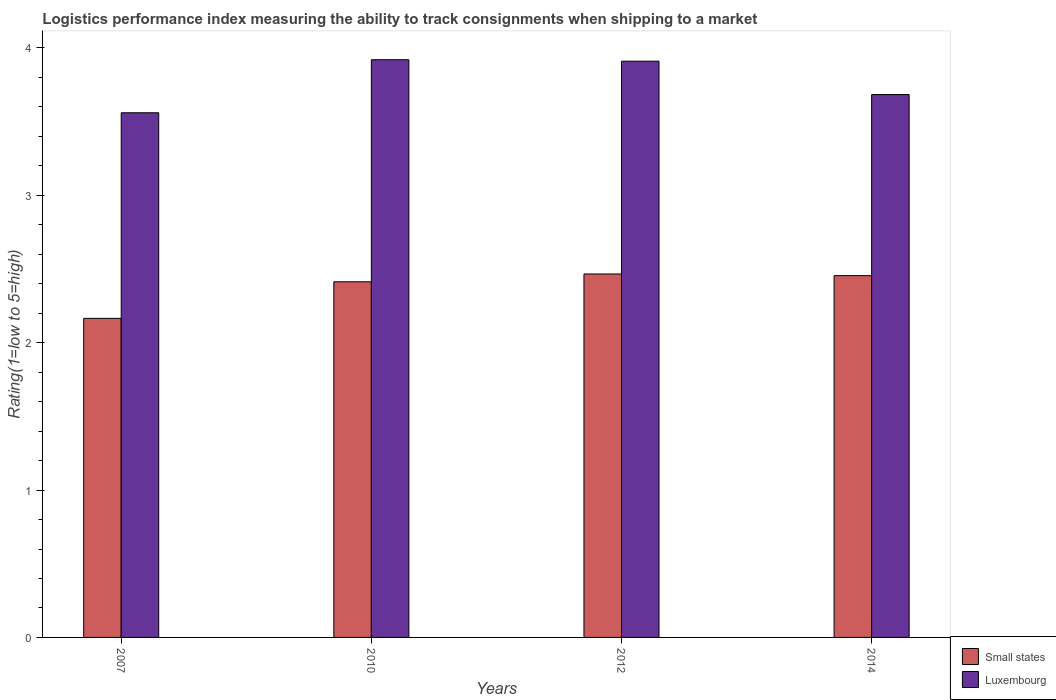How many different coloured bars are there?
Give a very brief answer. 2. How many groups of bars are there?
Your answer should be very brief. 4. Are the number of bars on each tick of the X-axis equal?
Keep it short and to the point. Yes. How many bars are there on the 3rd tick from the left?
Offer a terse response. 2. What is the label of the 2nd group of bars from the left?
Keep it short and to the point. 2010. What is the Logistic performance index in Luxembourg in 2012?
Your response must be concise. 3.91. Across all years, what is the maximum Logistic performance index in Luxembourg?
Provide a short and direct response. 3.92. Across all years, what is the minimum Logistic performance index in Luxembourg?
Offer a terse response. 3.56. In which year was the Logistic performance index in Small states maximum?
Offer a very short reply. 2012. In which year was the Logistic performance index in Luxembourg minimum?
Offer a terse response. 2007. What is the total Logistic performance index in Small states in the graph?
Offer a terse response. 9.5. What is the difference between the Logistic performance index in Luxembourg in 2012 and that in 2014?
Your answer should be compact. 0.23. What is the difference between the Logistic performance index in Small states in 2010 and the Logistic performance index in Luxembourg in 2014?
Your answer should be compact. -1.27. What is the average Logistic performance index in Small states per year?
Provide a short and direct response. 2.37. In the year 2007, what is the difference between the Logistic performance index in Small states and Logistic performance index in Luxembourg?
Your response must be concise. -1.4. In how many years, is the Logistic performance index in Luxembourg greater than 1?
Provide a succinct answer. 4. What is the ratio of the Logistic performance index in Small states in 2012 to that in 2014?
Ensure brevity in your answer.  1. What is the difference between the highest and the second highest Logistic performance index in Small states?
Your response must be concise. 0.01. What is the difference between the highest and the lowest Logistic performance index in Small states?
Your response must be concise. 0.3. What does the 2nd bar from the left in 2014 represents?
Ensure brevity in your answer.  Luxembourg. What does the 1st bar from the right in 2014 represents?
Provide a short and direct response. Luxembourg. How many bars are there?
Make the answer very short. 8. What is the difference between two consecutive major ticks on the Y-axis?
Your answer should be compact. 1. How are the legend labels stacked?
Make the answer very short. Vertical. What is the title of the graph?
Provide a succinct answer. Logistics performance index measuring the ability to track consignments when shipping to a market. Does "Kuwait" appear as one of the legend labels in the graph?
Your answer should be very brief. No. What is the label or title of the Y-axis?
Make the answer very short. Rating(1=low to 5=high). What is the Rating(1=low to 5=high) of Small states in 2007?
Provide a short and direct response. 2.17. What is the Rating(1=low to 5=high) of Luxembourg in 2007?
Offer a terse response. 3.56. What is the Rating(1=low to 5=high) of Small states in 2010?
Keep it short and to the point. 2.41. What is the Rating(1=low to 5=high) in Luxembourg in 2010?
Offer a very short reply. 3.92. What is the Rating(1=low to 5=high) in Small states in 2012?
Make the answer very short. 2.47. What is the Rating(1=low to 5=high) in Luxembourg in 2012?
Keep it short and to the point. 3.91. What is the Rating(1=low to 5=high) in Small states in 2014?
Keep it short and to the point. 2.45. What is the Rating(1=low to 5=high) of Luxembourg in 2014?
Provide a succinct answer. 3.68. Across all years, what is the maximum Rating(1=low to 5=high) of Small states?
Provide a succinct answer. 2.47. Across all years, what is the maximum Rating(1=low to 5=high) of Luxembourg?
Your answer should be very brief. 3.92. Across all years, what is the minimum Rating(1=low to 5=high) of Small states?
Provide a succinct answer. 2.17. Across all years, what is the minimum Rating(1=low to 5=high) of Luxembourg?
Ensure brevity in your answer.  3.56. What is the total Rating(1=low to 5=high) of Small states in the graph?
Make the answer very short. 9.5. What is the total Rating(1=low to 5=high) of Luxembourg in the graph?
Your response must be concise. 15.07. What is the difference between the Rating(1=low to 5=high) of Small states in 2007 and that in 2010?
Your response must be concise. -0.25. What is the difference between the Rating(1=low to 5=high) in Luxembourg in 2007 and that in 2010?
Offer a very short reply. -0.36. What is the difference between the Rating(1=low to 5=high) of Small states in 2007 and that in 2012?
Keep it short and to the point. -0.3. What is the difference between the Rating(1=low to 5=high) of Luxembourg in 2007 and that in 2012?
Offer a very short reply. -0.35. What is the difference between the Rating(1=low to 5=high) in Small states in 2007 and that in 2014?
Make the answer very short. -0.29. What is the difference between the Rating(1=low to 5=high) of Luxembourg in 2007 and that in 2014?
Keep it short and to the point. -0.12. What is the difference between the Rating(1=low to 5=high) in Small states in 2010 and that in 2012?
Offer a terse response. -0.05. What is the difference between the Rating(1=low to 5=high) in Small states in 2010 and that in 2014?
Offer a terse response. -0.04. What is the difference between the Rating(1=low to 5=high) in Luxembourg in 2010 and that in 2014?
Your answer should be very brief. 0.24. What is the difference between the Rating(1=low to 5=high) of Small states in 2012 and that in 2014?
Keep it short and to the point. 0.01. What is the difference between the Rating(1=low to 5=high) in Luxembourg in 2012 and that in 2014?
Your answer should be compact. 0.23. What is the difference between the Rating(1=low to 5=high) of Small states in 2007 and the Rating(1=low to 5=high) of Luxembourg in 2010?
Your answer should be compact. -1.75. What is the difference between the Rating(1=low to 5=high) in Small states in 2007 and the Rating(1=low to 5=high) in Luxembourg in 2012?
Provide a short and direct response. -1.75. What is the difference between the Rating(1=low to 5=high) in Small states in 2007 and the Rating(1=low to 5=high) in Luxembourg in 2014?
Keep it short and to the point. -1.52. What is the difference between the Rating(1=low to 5=high) in Small states in 2010 and the Rating(1=low to 5=high) in Luxembourg in 2012?
Provide a short and direct response. -1.5. What is the difference between the Rating(1=low to 5=high) of Small states in 2010 and the Rating(1=low to 5=high) of Luxembourg in 2014?
Your answer should be compact. -1.27. What is the difference between the Rating(1=low to 5=high) of Small states in 2012 and the Rating(1=low to 5=high) of Luxembourg in 2014?
Make the answer very short. -1.22. What is the average Rating(1=low to 5=high) in Small states per year?
Offer a very short reply. 2.37. What is the average Rating(1=low to 5=high) of Luxembourg per year?
Offer a very short reply. 3.77. In the year 2007, what is the difference between the Rating(1=low to 5=high) of Small states and Rating(1=low to 5=high) of Luxembourg?
Offer a very short reply. -1.4. In the year 2010, what is the difference between the Rating(1=low to 5=high) in Small states and Rating(1=low to 5=high) in Luxembourg?
Your answer should be very brief. -1.51. In the year 2012, what is the difference between the Rating(1=low to 5=high) of Small states and Rating(1=low to 5=high) of Luxembourg?
Keep it short and to the point. -1.44. In the year 2014, what is the difference between the Rating(1=low to 5=high) in Small states and Rating(1=low to 5=high) in Luxembourg?
Offer a terse response. -1.23. What is the ratio of the Rating(1=low to 5=high) of Small states in 2007 to that in 2010?
Provide a short and direct response. 0.9. What is the ratio of the Rating(1=low to 5=high) in Luxembourg in 2007 to that in 2010?
Make the answer very short. 0.91. What is the ratio of the Rating(1=low to 5=high) of Small states in 2007 to that in 2012?
Keep it short and to the point. 0.88. What is the ratio of the Rating(1=low to 5=high) in Luxembourg in 2007 to that in 2012?
Offer a very short reply. 0.91. What is the ratio of the Rating(1=low to 5=high) in Small states in 2007 to that in 2014?
Provide a short and direct response. 0.88. What is the ratio of the Rating(1=low to 5=high) of Luxembourg in 2007 to that in 2014?
Give a very brief answer. 0.97. What is the ratio of the Rating(1=low to 5=high) of Small states in 2010 to that in 2012?
Keep it short and to the point. 0.98. What is the ratio of the Rating(1=low to 5=high) of Luxembourg in 2010 to that in 2012?
Give a very brief answer. 1. What is the ratio of the Rating(1=low to 5=high) in Small states in 2010 to that in 2014?
Provide a succinct answer. 0.98. What is the ratio of the Rating(1=low to 5=high) of Luxembourg in 2010 to that in 2014?
Provide a succinct answer. 1.06. What is the ratio of the Rating(1=low to 5=high) in Luxembourg in 2012 to that in 2014?
Make the answer very short. 1.06. What is the difference between the highest and the second highest Rating(1=low to 5=high) of Small states?
Provide a succinct answer. 0.01. What is the difference between the highest and the lowest Rating(1=low to 5=high) of Small states?
Offer a very short reply. 0.3. What is the difference between the highest and the lowest Rating(1=low to 5=high) in Luxembourg?
Ensure brevity in your answer.  0.36. 